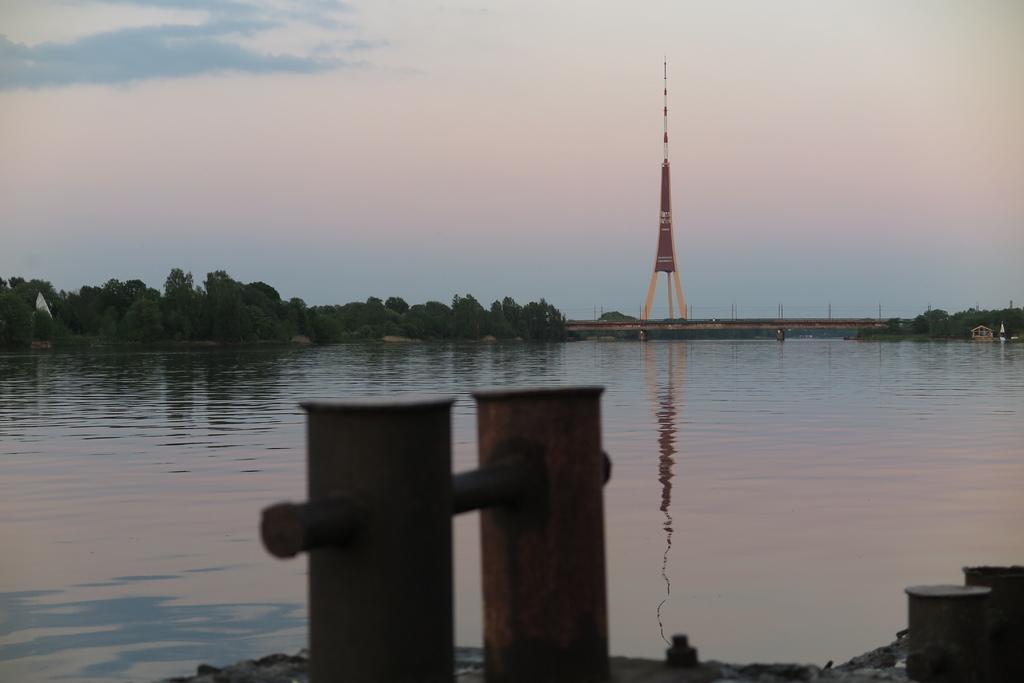Could you give a brief overview of what you see in this image? In this picture we can see a pot, signal tower, around we can see so many trees. 